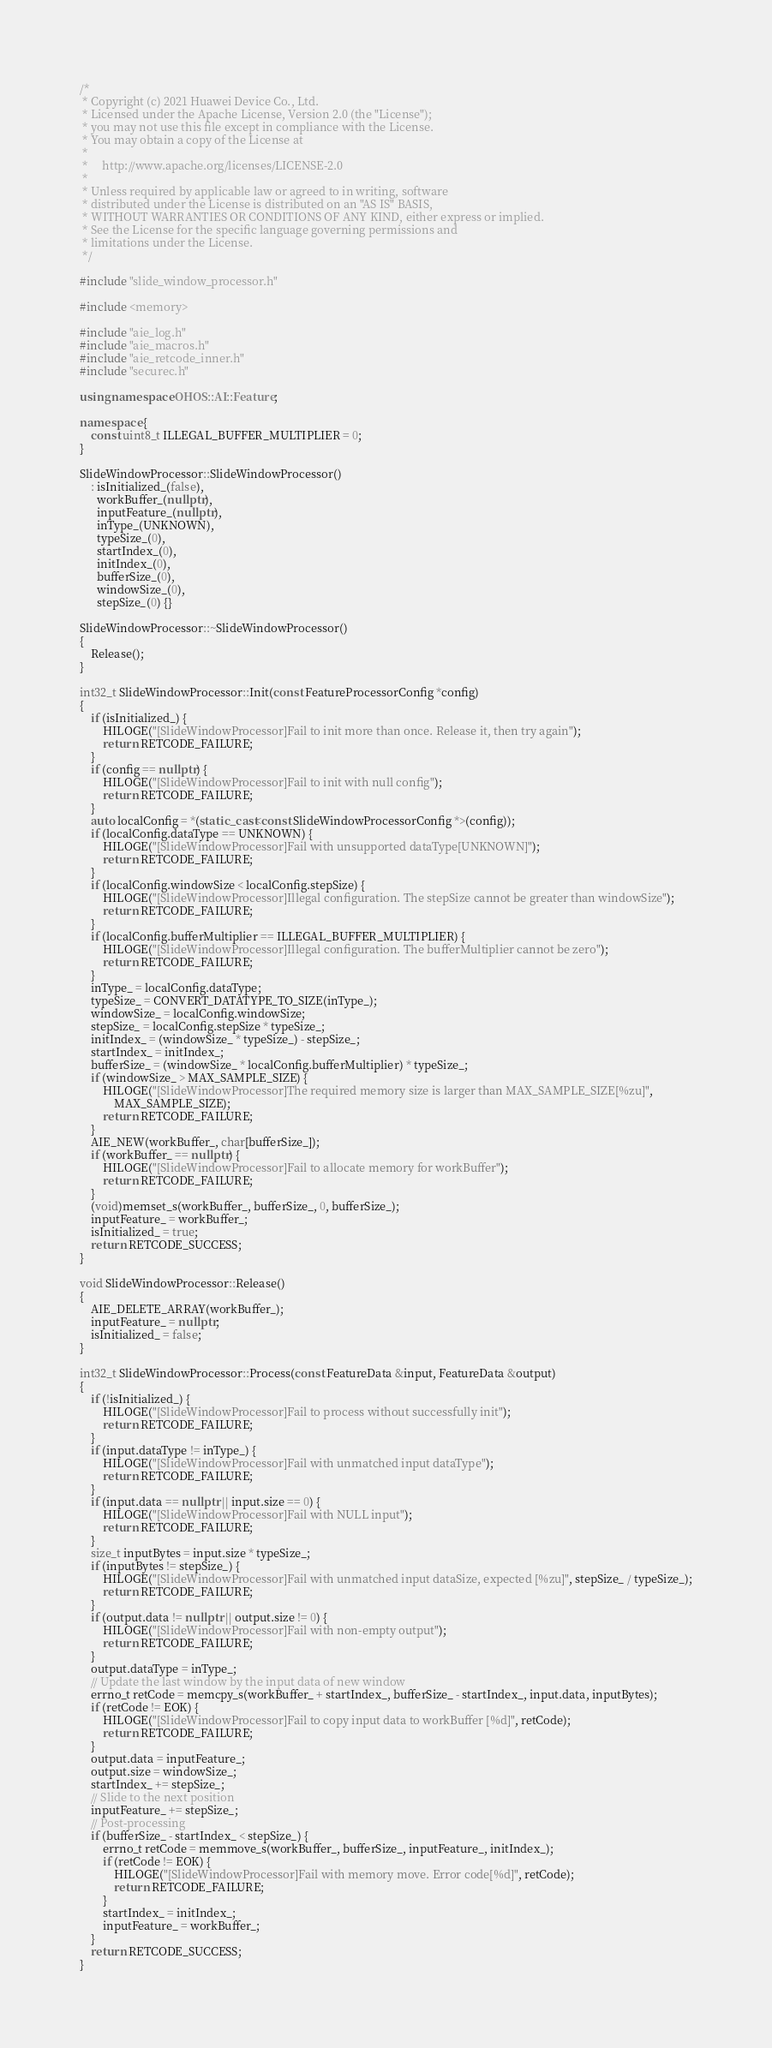Convert code to text. <code><loc_0><loc_0><loc_500><loc_500><_C++_>/*
 * Copyright (c) 2021 Huawei Device Co., Ltd.
 * Licensed under the Apache License, Version 2.0 (the "License");
 * you may not use this file except in compliance with the License.
 * You may obtain a copy of the License at
 *
 *     http://www.apache.org/licenses/LICENSE-2.0
 *
 * Unless required by applicable law or agreed to in writing, software
 * distributed under the License is distributed on an "AS IS" BASIS,
 * WITHOUT WARRANTIES OR CONDITIONS OF ANY KIND, either express or implied.
 * See the License for the specific language governing permissions and
 * limitations under the License.
 */

#include "slide_window_processor.h"

#include <memory>

#include "aie_log.h"
#include "aie_macros.h"
#include "aie_retcode_inner.h"
#include "securec.h"

using namespace OHOS::AI::Feature;

namespace {
    const uint8_t ILLEGAL_BUFFER_MULTIPLIER = 0;
}

SlideWindowProcessor::SlideWindowProcessor()
    : isInitialized_(false),
      workBuffer_(nullptr),
      inputFeature_(nullptr),
      inType_(UNKNOWN),
      typeSize_(0),
      startIndex_(0),
      initIndex_(0),
      bufferSize_(0),
      windowSize_(0),
      stepSize_(0) {}

SlideWindowProcessor::~SlideWindowProcessor()
{
    Release();
}

int32_t SlideWindowProcessor::Init(const FeatureProcessorConfig *config)
{
    if (isInitialized_) {
        HILOGE("[SlideWindowProcessor]Fail to init more than once. Release it, then try again");
        return RETCODE_FAILURE;
    }
    if (config == nullptr) {
        HILOGE("[SlideWindowProcessor]Fail to init with null config");
        return RETCODE_FAILURE;
    }
    auto localConfig = *(static_cast<const SlideWindowProcessorConfig *>(config));
    if (localConfig.dataType == UNKNOWN) {
        HILOGE("[SlideWindowProcessor]Fail with unsupported dataType[UNKNOWN]");
        return RETCODE_FAILURE;
    }
    if (localConfig.windowSize < localConfig.stepSize) {
        HILOGE("[SlideWindowProcessor]Illegal configuration. The stepSize cannot be greater than windowSize");
        return RETCODE_FAILURE;
    }
    if (localConfig.bufferMultiplier == ILLEGAL_BUFFER_MULTIPLIER) {
        HILOGE("[SlideWindowProcessor]Illegal configuration. The bufferMultiplier cannot be zero");
        return RETCODE_FAILURE;
    }
    inType_ = localConfig.dataType;
    typeSize_ = CONVERT_DATATYPE_TO_SIZE(inType_);
    windowSize_ = localConfig.windowSize;
    stepSize_ = localConfig.stepSize * typeSize_;
    initIndex_ = (windowSize_ * typeSize_) - stepSize_;
    startIndex_ = initIndex_;
    bufferSize_ = (windowSize_ * localConfig.bufferMultiplier) * typeSize_;
    if (windowSize_ > MAX_SAMPLE_SIZE) {
        HILOGE("[SlideWindowProcessor]The required memory size is larger than MAX_SAMPLE_SIZE[%zu]",
            MAX_SAMPLE_SIZE);
        return RETCODE_FAILURE;
    }
    AIE_NEW(workBuffer_, char[bufferSize_]);
    if (workBuffer_ == nullptr) {
        HILOGE("[SlideWindowProcessor]Fail to allocate memory for workBuffer");
        return RETCODE_FAILURE;
    }
    (void)memset_s(workBuffer_, bufferSize_, 0, bufferSize_);
    inputFeature_ = workBuffer_;
    isInitialized_ = true;
    return RETCODE_SUCCESS;
}

void SlideWindowProcessor::Release()
{
    AIE_DELETE_ARRAY(workBuffer_);
    inputFeature_ = nullptr;
    isInitialized_ = false;
}

int32_t SlideWindowProcessor::Process(const FeatureData &input, FeatureData &output)
{
    if (!isInitialized_) {
        HILOGE("[SlideWindowProcessor]Fail to process without successfully init");
        return RETCODE_FAILURE;
    }
    if (input.dataType != inType_) {
        HILOGE("[SlideWindowProcessor]Fail with unmatched input dataType");
        return RETCODE_FAILURE;
    }
    if (input.data == nullptr || input.size == 0) {
        HILOGE("[SlideWindowProcessor]Fail with NULL input");
        return RETCODE_FAILURE;
    }
    size_t inputBytes = input.size * typeSize_;
    if (inputBytes != stepSize_) {
        HILOGE("[SlideWindowProcessor]Fail with unmatched input dataSize, expected [%zu]", stepSize_ / typeSize_);
        return RETCODE_FAILURE;
    }
    if (output.data != nullptr || output.size != 0) {
        HILOGE("[SlideWindowProcessor]Fail with non-empty output");
        return RETCODE_FAILURE;
    }
    output.dataType = inType_;
    // Update the last window by the input data of new window
    errno_t retCode = memcpy_s(workBuffer_ + startIndex_, bufferSize_ - startIndex_, input.data, inputBytes);
    if (retCode != EOK) {
        HILOGE("[SlideWindowProcessor]Fail to copy input data to workBuffer [%d]", retCode);
        return RETCODE_FAILURE;
    }
    output.data = inputFeature_;
    output.size = windowSize_;
    startIndex_ += stepSize_;
    // Slide to the next position
    inputFeature_ += stepSize_;
    // Post-processing
    if (bufferSize_ - startIndex_ < stepSize_) {
        errno_t retCode = memmove_s(workBuffer_, bufferSize_, inputFeature_, initIndex_);
        if (retCode != EOK) {
            HILOGE("[SlideWindowProcessor]Fail with memory move. Error code[%d]", retCode);
            return RETCODE_FAILURE;
        }
        startIndex_ = initIndex_;
        inputFeature_ = workBuffer_;
    }
    return RETCODE_SUCCESS;
}</code> 